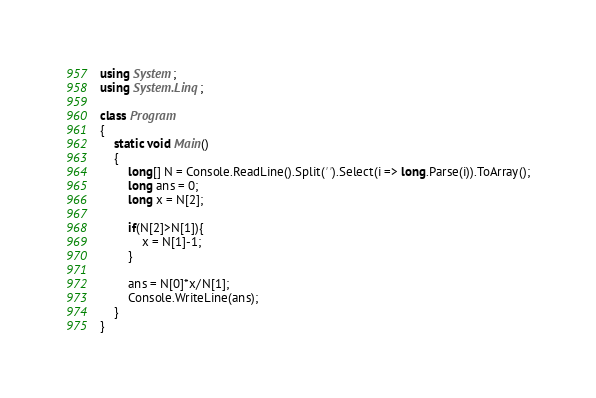Convert code to text. <code><loc_0><loc_0><loc_500><loc_500><_C#_>using System;
using System.Linq;

class Program
{
	static void Main()
    {
		long[] N = Console.ReadLine().Split(' ').Select(i => long.Parse(i)).ToArray();
		long ans = 0;
      	long x = N[2];
      
        if(N[2]>N[1]){
          	x = N[1]-1;
        }
      
       	ans = N[0]*x/N[1];
      	Console.WriteLine(ans);
    }
}</code> 